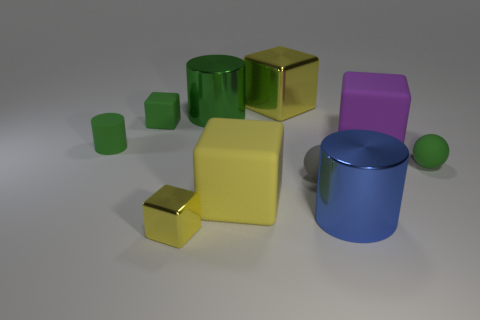Subtract all purple balls. How many yellow cubes are left? 3 Subtract 3 cubes. How many cubes are left? 2 Subtract all green cylinders. How many cylinders are left? 1 Subtract all purple blocks. How many blocks are left? 4 Subtract all blue blocks. Subtract all yellow balls. How many blocks are left? 5 Subtract all balls. How many objects are left? 8 Add 1 tiny green cylinders. How many tiny green cylinders exist? 2 Subtract 2 green cylinders. How many objects are left? 8 Subtract all yellow cylinders. Subtract all large cylinders. How many objects are left? 8 Add 7 tiny green things. How many tiny green things are left? 10 